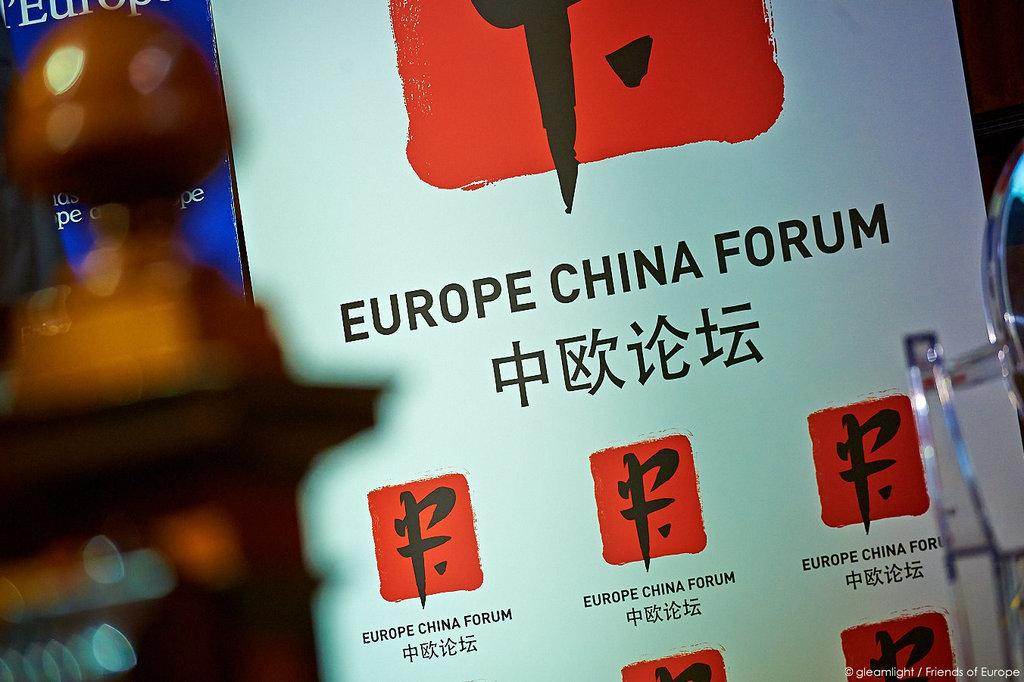<image>
Render a clear and concise summary of the photo. A white billboard with red and black symbols on it displays a notice that you are at the Europe China Forum. 